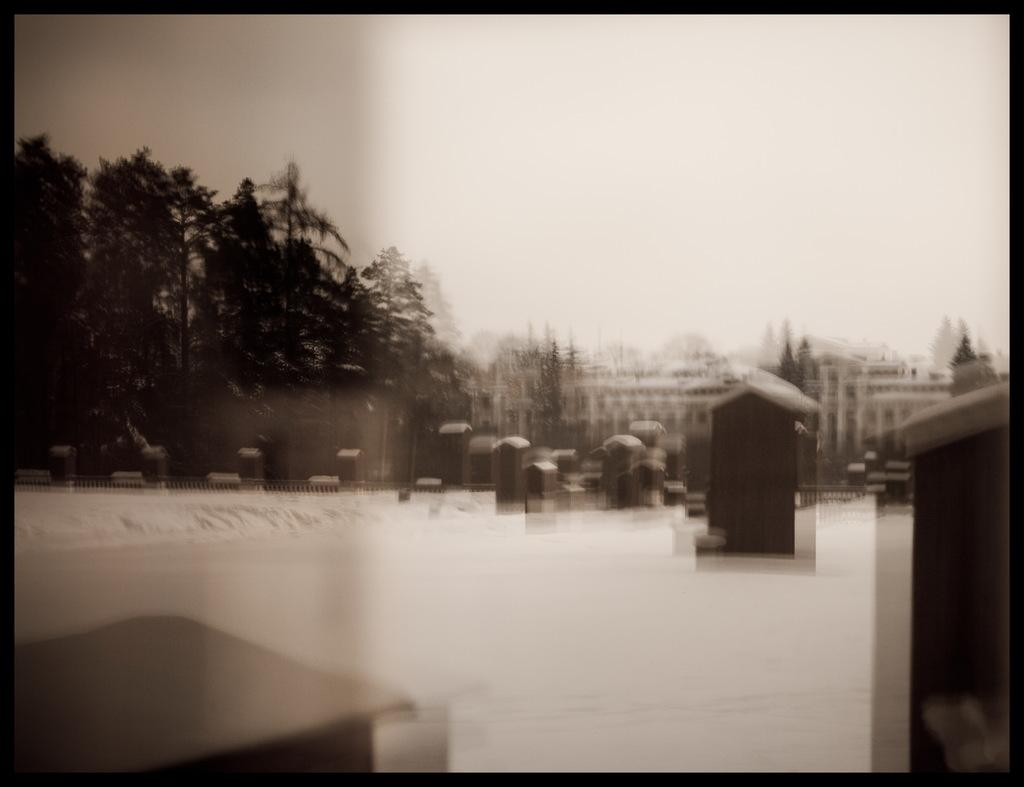What is the visual quality of the image? The image is blurred. What color scheme is used in the image? The image is black and white. What type of natural vegetation can be seen in the image? There are trees in the image. What type of man-made structures are present in the image? There are buildings in the image. What type of care can be seen being provided to the tin in the image? There is no tin or care being provided in the image; it features trees and buildings. 